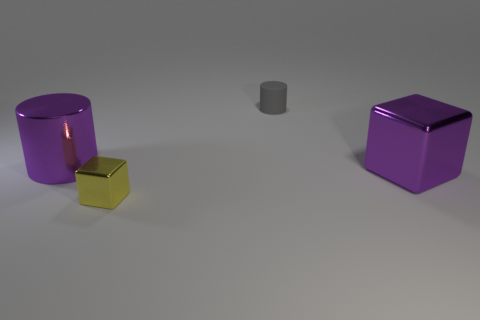Add 1 small yellow matte cubes. How many objects exist? 5 Add 3 purple shiny blocks. How many purple shiny blocks are left? 4 Add 2 large blocks. How many large blocks exist? 3 Subtract 0 gray balls. How many objects are left? 4 Subtract all big purple cylinders. Subtract all tiny yellow blocks. How many objects are left? 2 